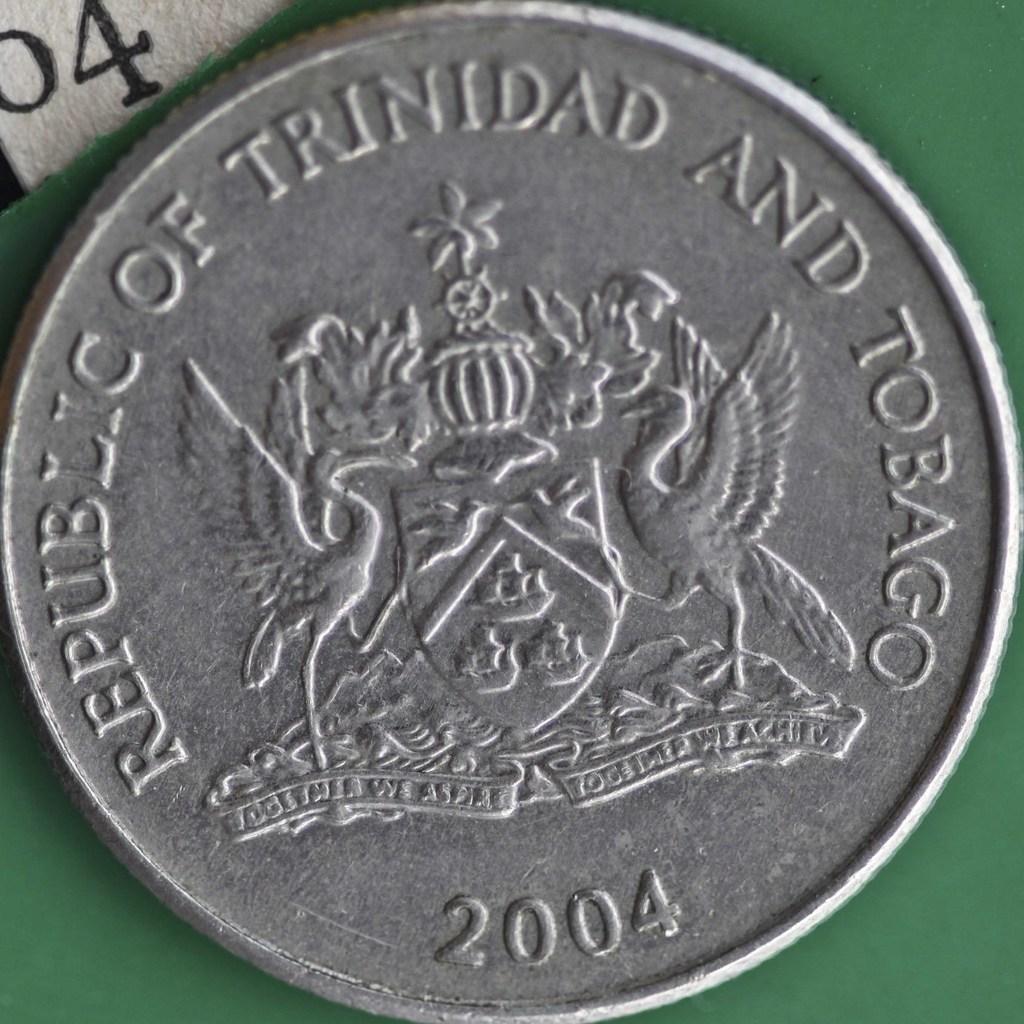What country is this coin from?
Provide a short and direct response. Trinidad. What is the year on the coin?
Offer a very short reply. 2004. 